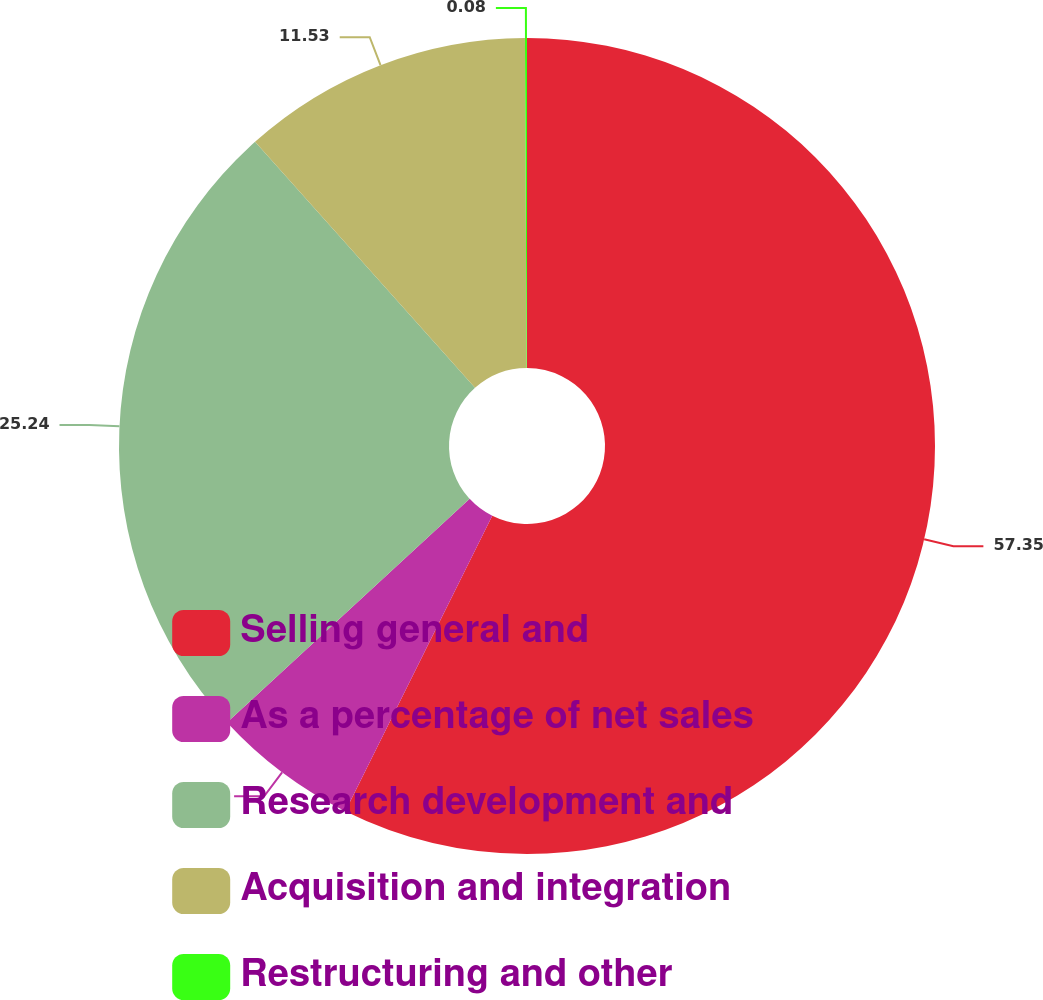Convert chart to OTSL. <chart><loc_0><loc_0><loc_500><loc_500><pie_chart><fcel>Selling general and<fcel>As a percentage of net sales<fcel>Research development and<fcel>Acquisition and integration<fcel>Restructuring and other<nl><fcel>57.34%<fcel>5.8%<fcel>25.24%<fcel>11.53%<fcel>0.08%<nl></chart> 